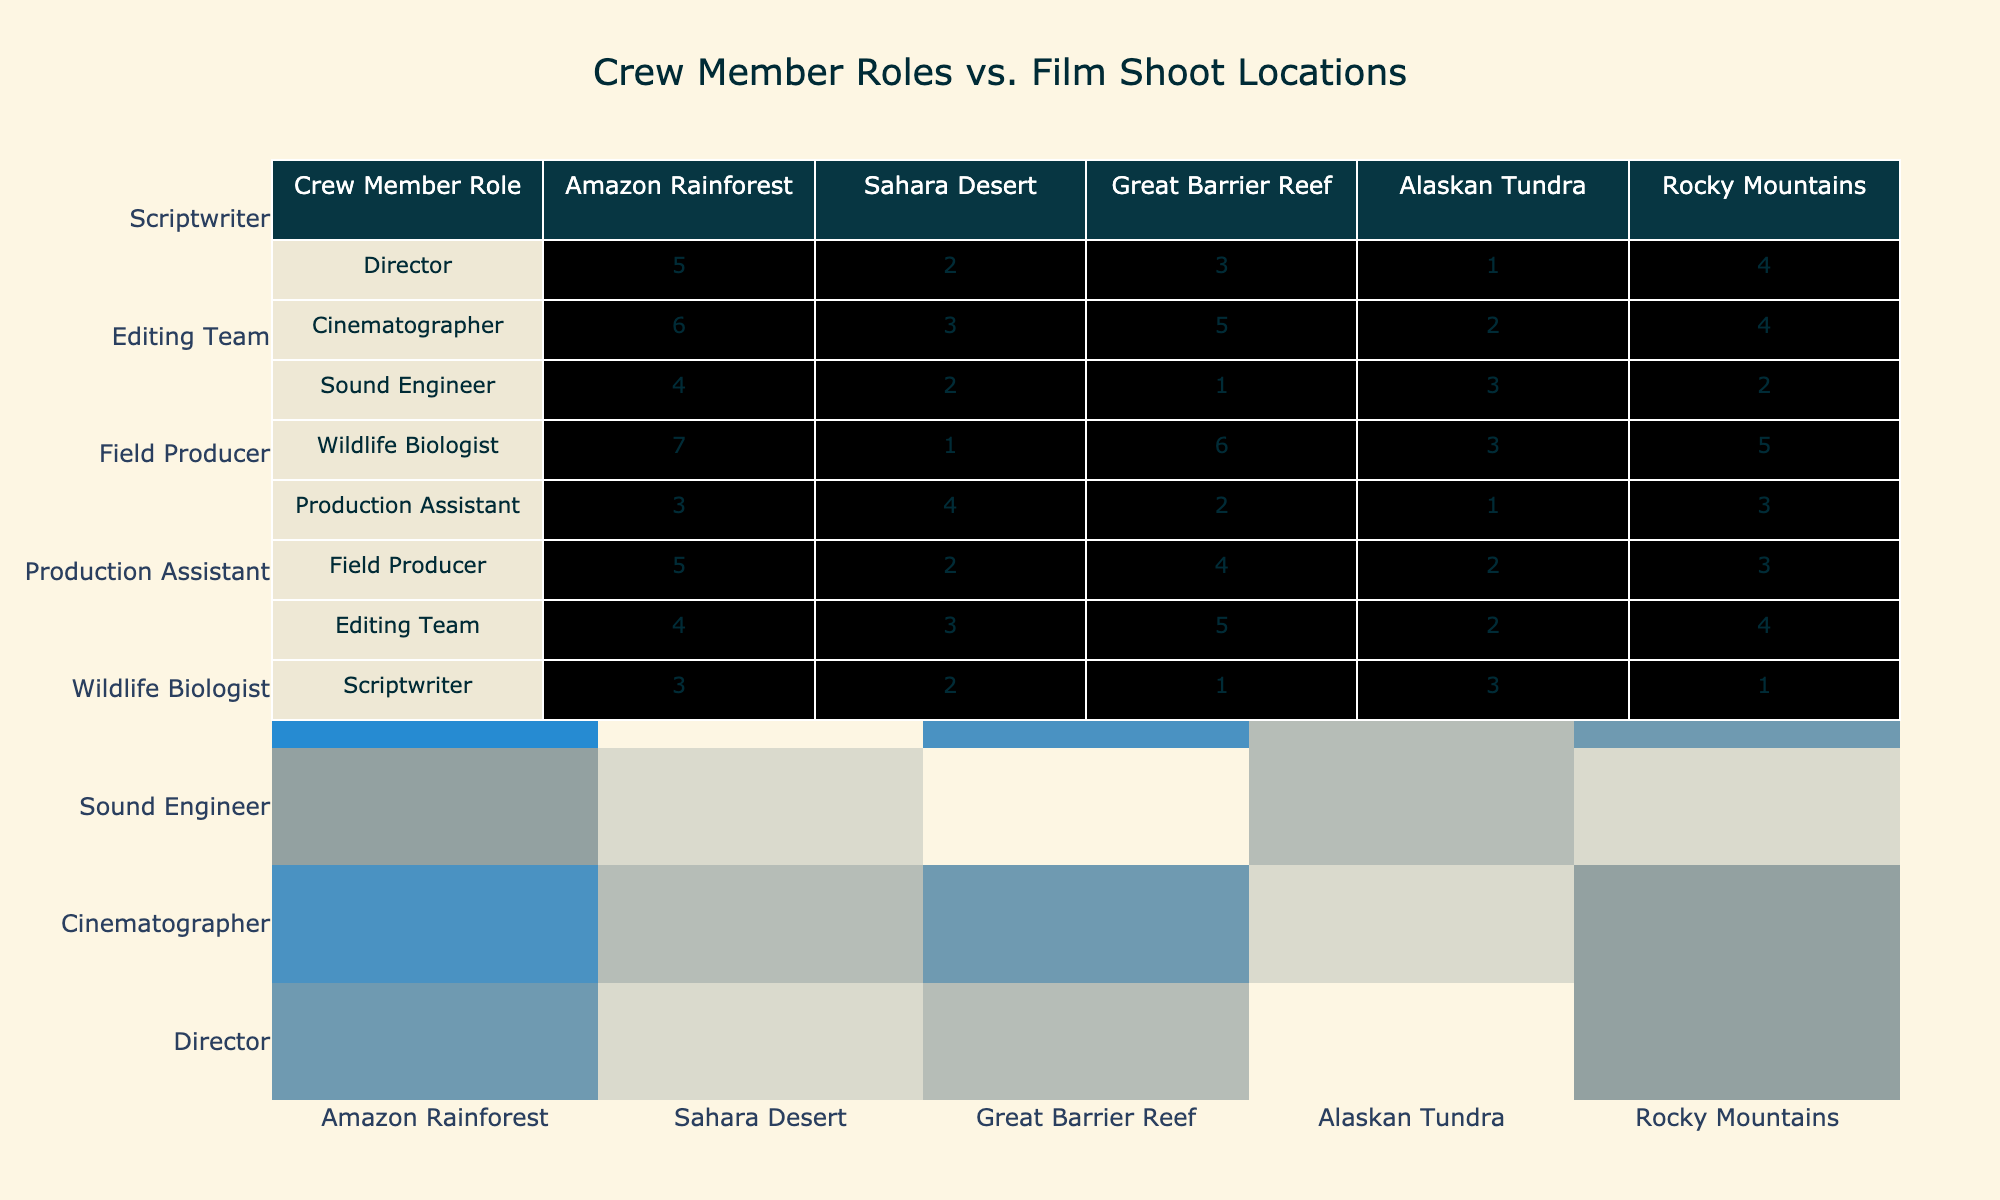What is the highest number of crew members for the Wildlife Biologist role in any location? The table shows that the Wildlife Biologist has the highest count of crew members in the Great Barrier Reef, where the count is 6.
Answer: 6 Which location has the fewest Sound Engineers? The table indicates that the Sahara Desert has the fewest Sound Engineers, with a count of 2.
Answer: 2 What is the total number of crew members for the Cinematographer across all locations? To find the total for the Cinematographer, we add up the values: 6 + 3 + 5 + 2 + 4 = 20.
Answer: 20 Are there more Production Assistants in the Sahara Desert than in the Alaskan Tundra? The table shows that there are 4 Production Assistants in the Sahara Desert and only 1 in the Alaskan Tundra. Therefore, the statement is true.
Answer: Yes Which crew member role has the highest total across all locations? We can find the total for each role and compare them. The totals are: Director (15), Cinematographer (20), Sound Engineer (12), Wildlife Biologist (22), Production Assistant (13), Field Producer (14), Editing Team (18), and Scriptwriter (10). The highest total is for the Wildlife Biologist at 22.
Answer: Wildlife Biologist What is the difference in crew members between the Director role and the Editing Team across the Great Barrier Reef? For the Great Barrier Reef, the Director has 3 crew members and the Editing Team has 5. The difference is calculated as 5 - 3 = 2.
Answer: 2 Is there a higher number of crew members for the Field Producer role in the Rocky Mountains than in the Amazon Rainforest? The table shows that the Field Producer has 3 in the Rocky Mountains and 5 in the Amazon Rainforest. Therefore, the statement is false.
Answer: No What is the average number of crew members for the Scriptwriter role across all locations? To calculate the average, we sum the Scriptwriter counts: 3 + 2 + 1 + 3 + 1 = 10. There are 5 locations, so the average is 10/5 = 2.
Answer: 2 Which location has the highest total number of crew members across all roles combined? We add up the crew members for each location: Amazon Rainforest (5+6+4+7+3+5+4+3=37), Sahara Desert (2+3+2+1+4+2+3+2=19), Great Barrier Reef (3+5+1+6+2+4+5+1=27), Alaskan Tundra (1+2+3+3+1+2+2+3=17), Rocky Mountains (4+4+2+5+3+3+4+1=28). The highest total is for the Amazon Rainforest with 37.
Answer: Amazon Rainforest 